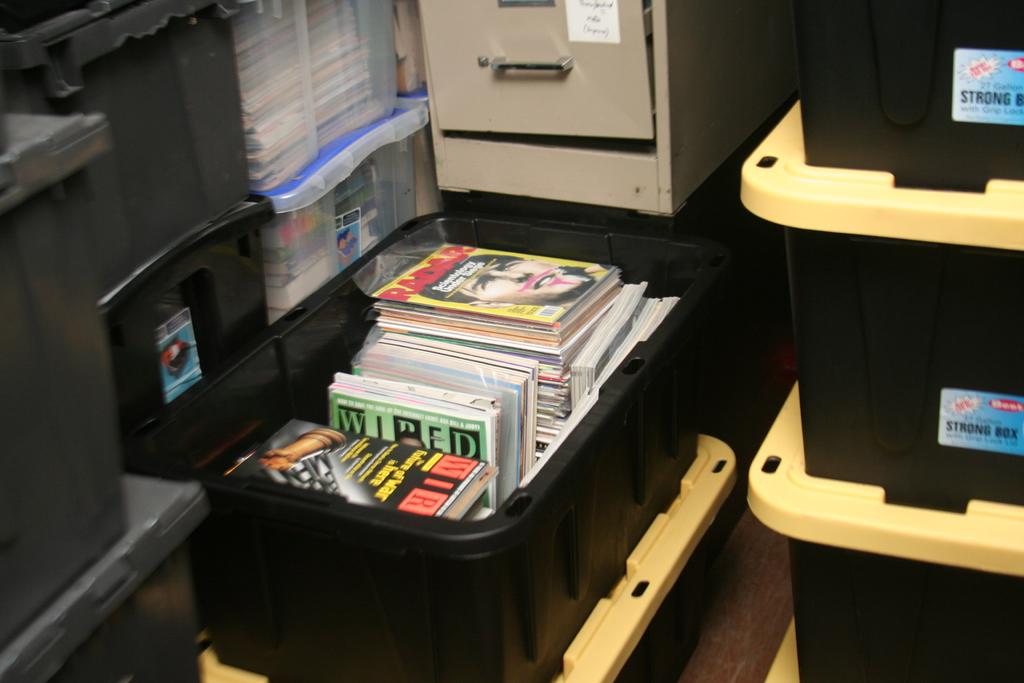What magazine has the green and black cover?
Your answer should be compact. Wired. Are those cds on the black container?
Your answer should be very brief. Yes. 